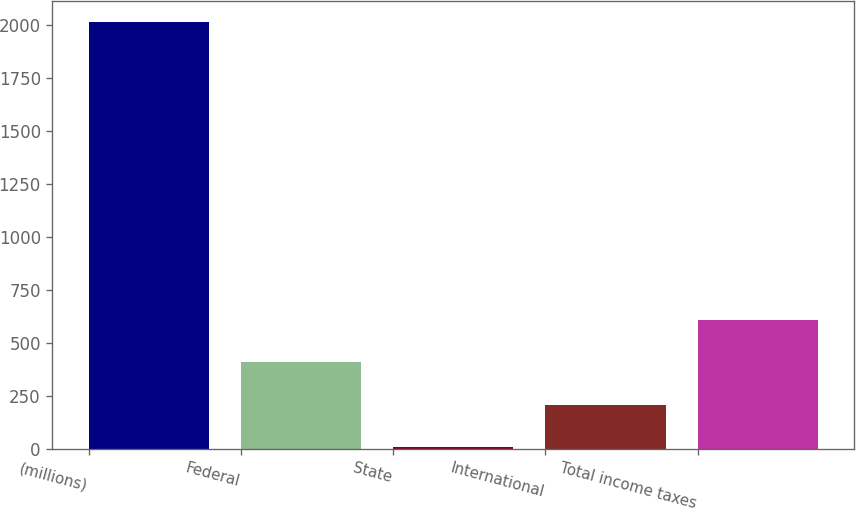Convert chart to OTSL. <chart><loc_0><loc_0><loc_500><loc_500><bar_chart><fcel>(millions)<fcel>Federal<fcel>State<fcel>International<fcel>Total income taxes<nl><fcel>2012<fcel>410.48<fcel>10.1<fcel>210.29<fcel>610.67<nl></chart> 